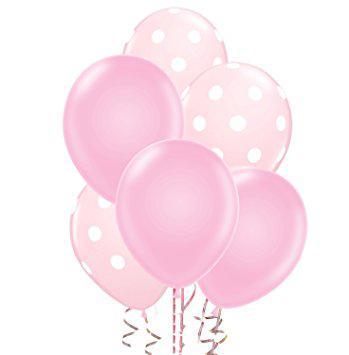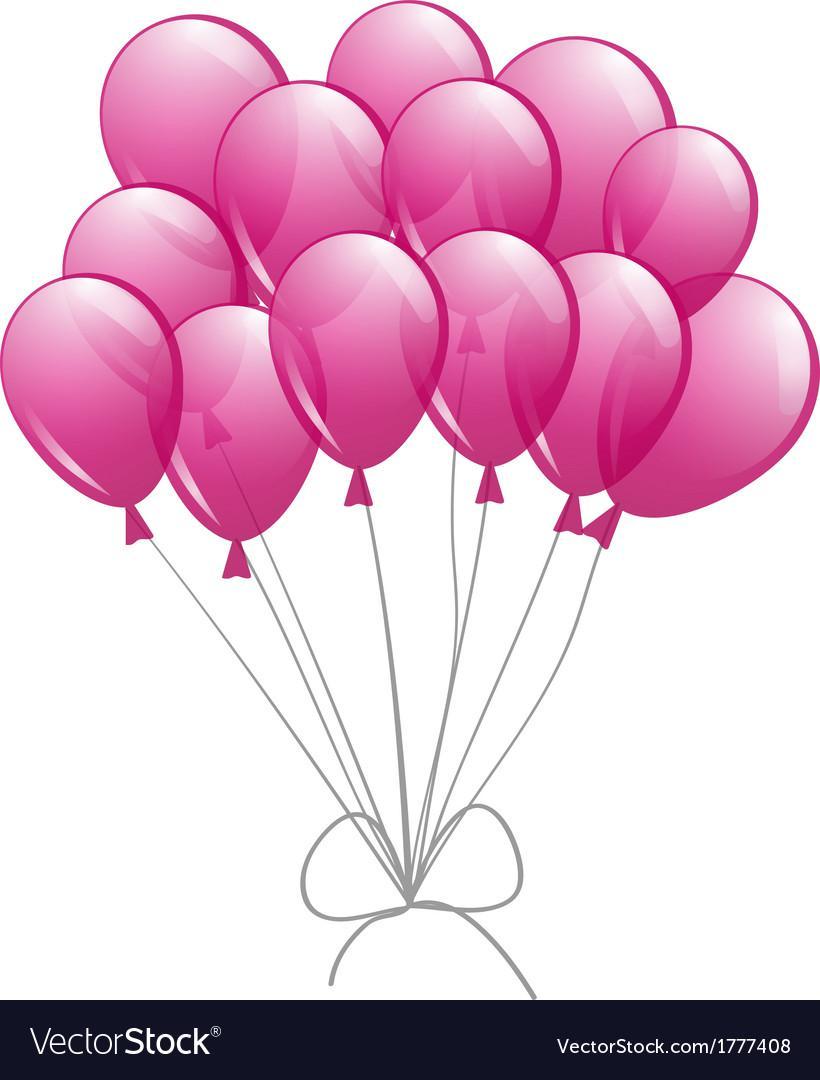The first image is the image on the left, the second image is the image on the right. Evaluate the accuracy of this statement regarding the images: "There are no less than 19 balloons.". Is it true? Answer yes or no. Yes. 